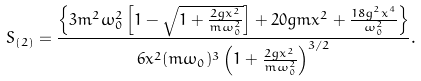Convert formula to latex. <formula><loc_0><loc_0><loc_500><loc_500>S _ { ( 2 ) } = \frac { \left \{ 3 m ^ { 2 } \omega _ { 0 } ^ { 2 } \left [ 1 - \sqrt { 1 + \frac { 2 g x ^ { 2 } } { m \omega _ { 0 } ^ { 2 } } } \right ] + 2 0 g m x ^ { 2 } + \frac { 1 8 g ^ { 2 } x ^ { 4 } } { \omega _ { 0 } ^ { 2 } } \right \} } { 6 x ^ { 2 } ( m \omega _ { 0 } ) ^ { 3 } \left ( 1 + \frac { 2 g x ^ { 2 } } { m \omega _ { 0 } ^ { 2 } } \right ) ^ { 3 / 2 } } .</formula> 